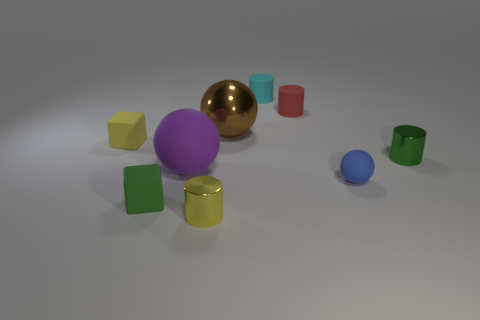Add 1 metallic blocks. How many objects exist? 10 Subtract all blocks. How many objects are left? 7 Add 4 cyan metallic things. How many cyan metallic things exist? 4 Subtract 0 purple cubes. How many objects are left? 9 Subtract all blue spheres. Subtract all small blue things. How many objects are left? 7 Add 4 tiny cyan cylinders. How many tiny cyan cylinders are left? 5 